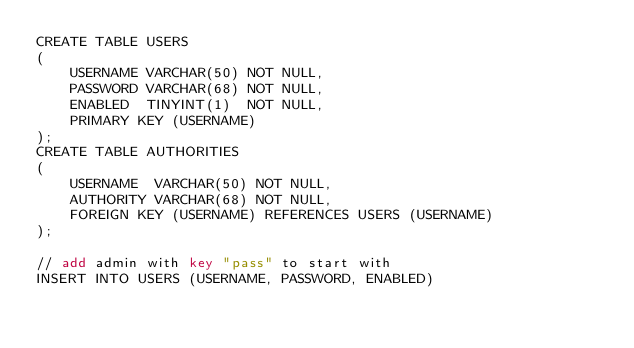Convert code to text. <code><loc_0><loc_0><loc_500><loc_500><_SQL_>CREATE TABLE USERS
(
    USERNAME VARCHAR(50) NOT NULL,
    PASSWORD VARCHAR(68) NOT NULL,
    ENABLED  TINYINT(1)  NOT NULL,
    PRIMARY KEY (USERNAME)
);
CREATE TABLE AUTHORITIES
(
    USERNAME  VARCHAR(50) NOT NULL,
    AUTHORITY VARCHAR(68) NOT NULL,
    FOREIGN KEY (USERNAME) REFERENCES USERS (USERNAME)
);

// add admin with key "pass" to start with
INSERT INTO USERS (USERNAME, PASSWORD, ENABLED)</code> 